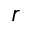Convert formula to latex. <formula><loc_0><loc_0><loc_500><loc_500>r</formula> 